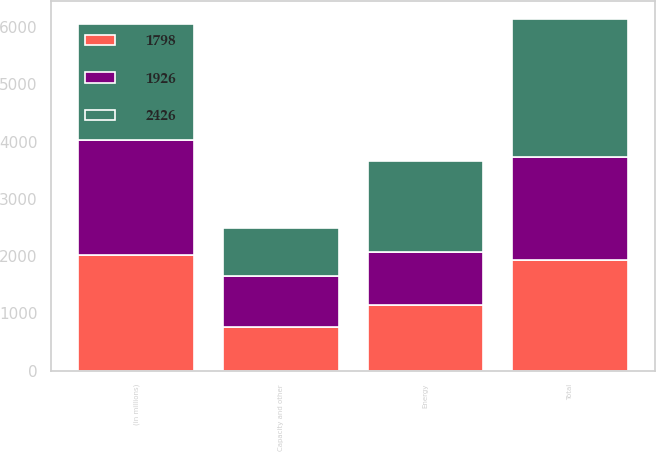<chart> <loc_0><loc_0><loc_500><loc_500><stacked_bar_chart><ecel><fcel>(in millions)<fcel>Capacity and other<fcel>Energy<fcel>Total<nl><fcel>2426<fcel>2017<fcel>838<fcel>1588<fcel>2426<nl><fcel>1798<fcel>2016<fcel>771<fcel>1155<fcel>1926<nl><fcel>1926<fcel>2015<fcel>875<fcel>923<fcel>1798<nl></chart> 